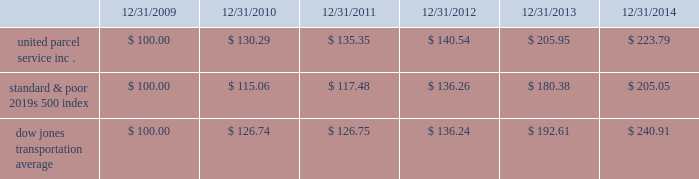Shareowner return performance graph the following performance graph and related information shall not be deemed 201csoliciting material 201d or to be 201cfiled 201d with the sec , nor shall such information be incorporated by reference into any future filing under the securities act of 1933 or securities exchange act of 1934 , each as amended , except to the extent that the company specifically incorporates such information by reference into such filing .
The following graph shows a five year comparison of cumulative total shareowners 2019 returns for our class b common stock , the standard & poor 2019s 500 index , and the dow jones transportation average .
The comparison of the total cumulative return on investment , which is the change in the quarterly stock price plus reinvested dividends for each of the quarterly periods , assumes that $ 100 was invested on december 31 , 2009 in the standard & poor 2019s 500 index , the dow jones transportation average , and our class b common stock. .

What is the roi of an investment in ups from 2010 to 2012? 
Computations: ((140.54 - 130.29) / 130.29)
Answer: 0.07867. 